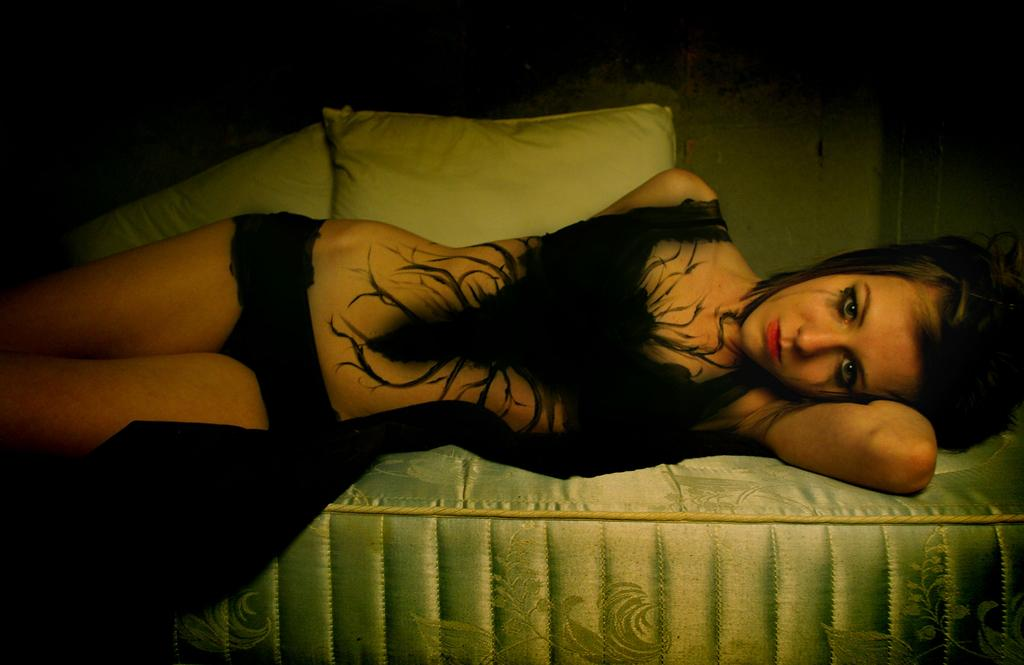Who is the main subject in the image? There is a girl in the image. What is the girl's position in the image? The girl is lying on a mattress. What objects are present in the image that might provide comfort or support? There are two white pillows in the image. Where are the pillows located in relation to the girl? The pillows are behind the girl. What type of grass can be seen growing on the girl's head in the image? There is no grass present in the image, and the girl's head is not shown. What scent is associated with the girl in the image? There is no mention of a scent in the image, and it is not possible to determine a scent based on the visual information provided. 